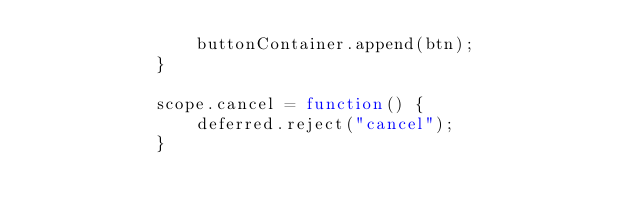Convert code to text. <code><loc_0><loc_0><loc_500><loc_500><_JavaScript_>				buttonContainer.append(btn);
			}

			scope.cancel = function() {
				deferred.reject("cancel");
			}
</code> 